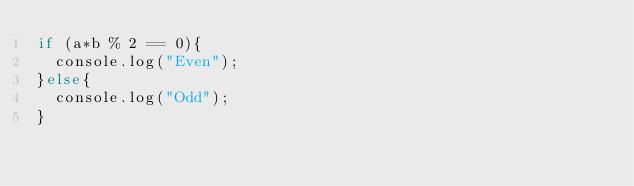Convert code to text. <code><loc_0><loc_0><loc_500><loc_500><_JavaScript_>if (a*b % 2 == 0){
  console.log("Even");
}else{
  console.log("Odd");
}</code> 